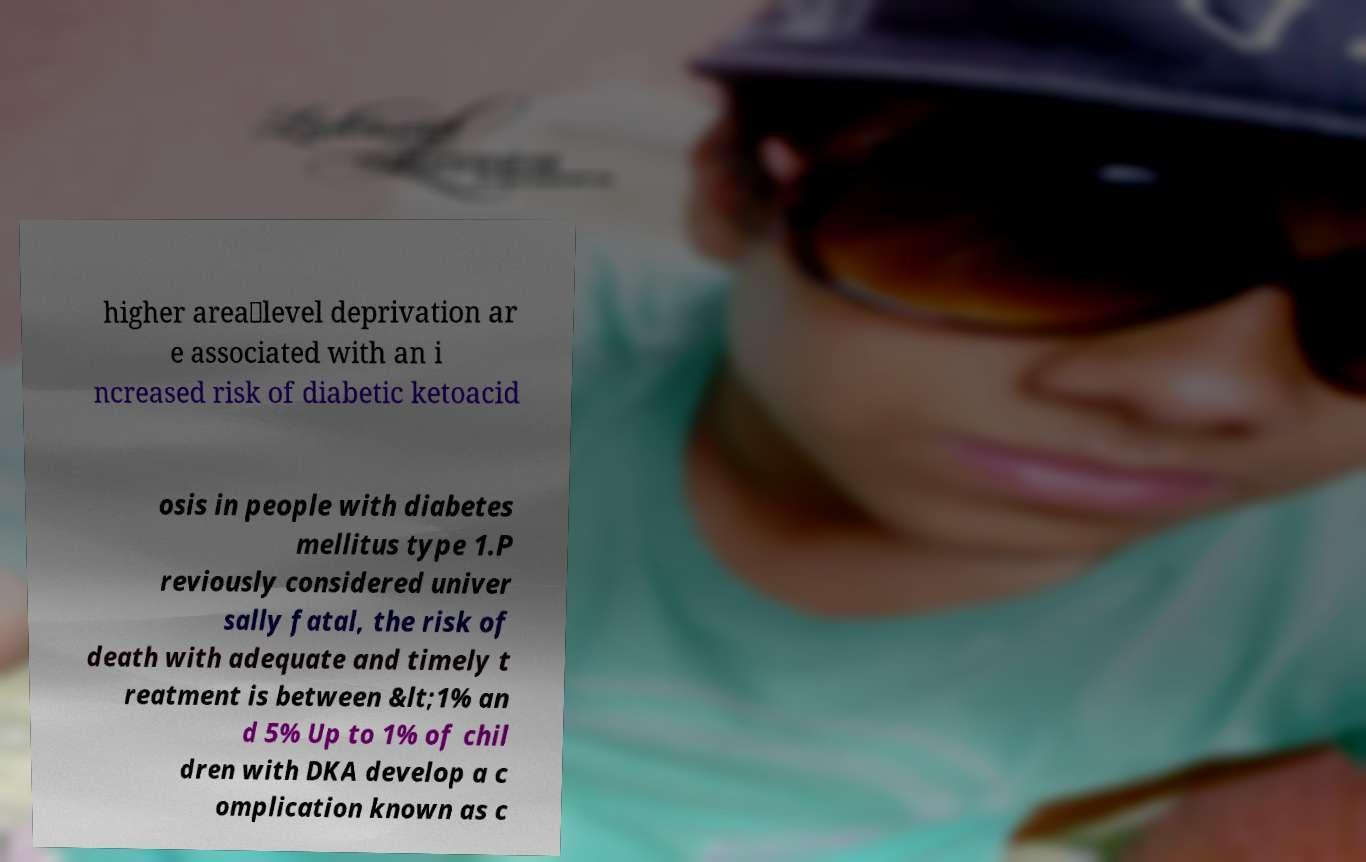Can you read and provide the text displayed in the image?This photo seems to have some interesting text. Can you extract and type it out for me? higher area‐level deprivation ar e associated with an i ncreased risk of diabetic ketoacid osis in people with diabetes mellitus type 1.P reviously considered univer sally fatal, the risk of death with adequate and timely t reatment is between &lt;1% an d 5% Up to 1% of chil dren with DKA develop a c omplication known as c 